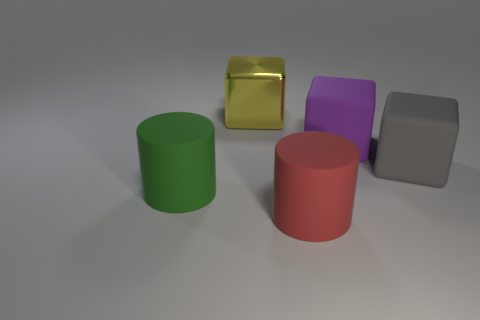Are there fewer green cylinders behind the big gray thing than tiny yellow metallic cylinders?
Keep it short and to the point. No. What is the shape of the big matte object that is in front of the big green thing?
Your response must be concise. Cylinder. There is a red cylinder; does it have the same size as the thing behind the large purple block?
Your answer should be very brief. Yes. Are there any green cylinders that have the same material as the large gray thing?
Offer a very short reply. Yes. How many cylinders are big red things or large purple rubber objects?
Provide a succinct answer. 1. Are there any things that are in front of the large green rubber cylinder that is on the left side of the large gray block?
Provide a short and direct response. Yes. Are there fewer cubes than rubber things?
Keep it short and to the point. Yes. What number of purple things have the same shape as the gray object?
Give a very brief answer. 1. What number of yellow things are either big things or big cubes?
Offer a terse response. 1. What is the size of the purple object behind the cylinder that is on the right side of the metallic block?
Keep it short and to the point. Large. 